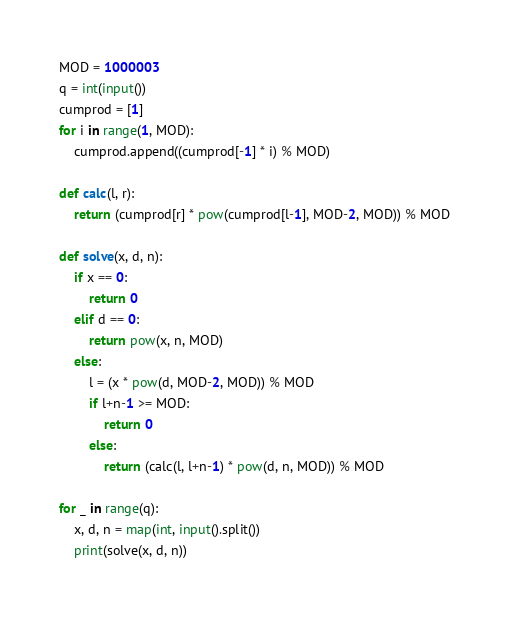<code> <loc_0><loc_0><loc_500><loc_500><_Python_>MOD = 1000003
q = int(input())
cumprod = [1]
for i in range(1, MOD):
	cumprod.append((cumprod[-1] * i) % MOD)

def calc(l, r):
	return (cumprod[r] * pow(cumprod[l-1], MOD-2, MOD)) % MOD

def solve(x, d, n):
	if x == 0:
		return 0
	elif d == 0:
		return pow(x, n, MOD)
	else:
		l = (x * pow(d, MOD-2, MOD)) % MOD
		if l+n-1 >= MOD:
			return 0
		else:
			return (calc(l, l+n-1) * pow(d, n, MOD)) % MOD

for _ in range(q):
	x, d, n = map(int, input().split())
	print(solve(x, d, n))</code> 